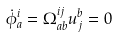Convert formula to latex. <formula><loc_0><loc_0><loc_500><loc_500>\dot { \phi } ^ { i } _ { a } = \Omega ^ { i j } _ { a b } u _ { j } ^ { b } = 0</formula> 